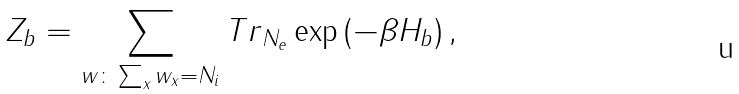Convert formula to latex. <formula><loc_0><loc_0><loc_500><loc_500>Z _ { b } = \sum _ { w \colon \sum _ { x } w _ { x } = N _ { i } } { T r } _ { N _ { e } } \exp \left ( - \beta H _ { b } \right ) ,</formula> 